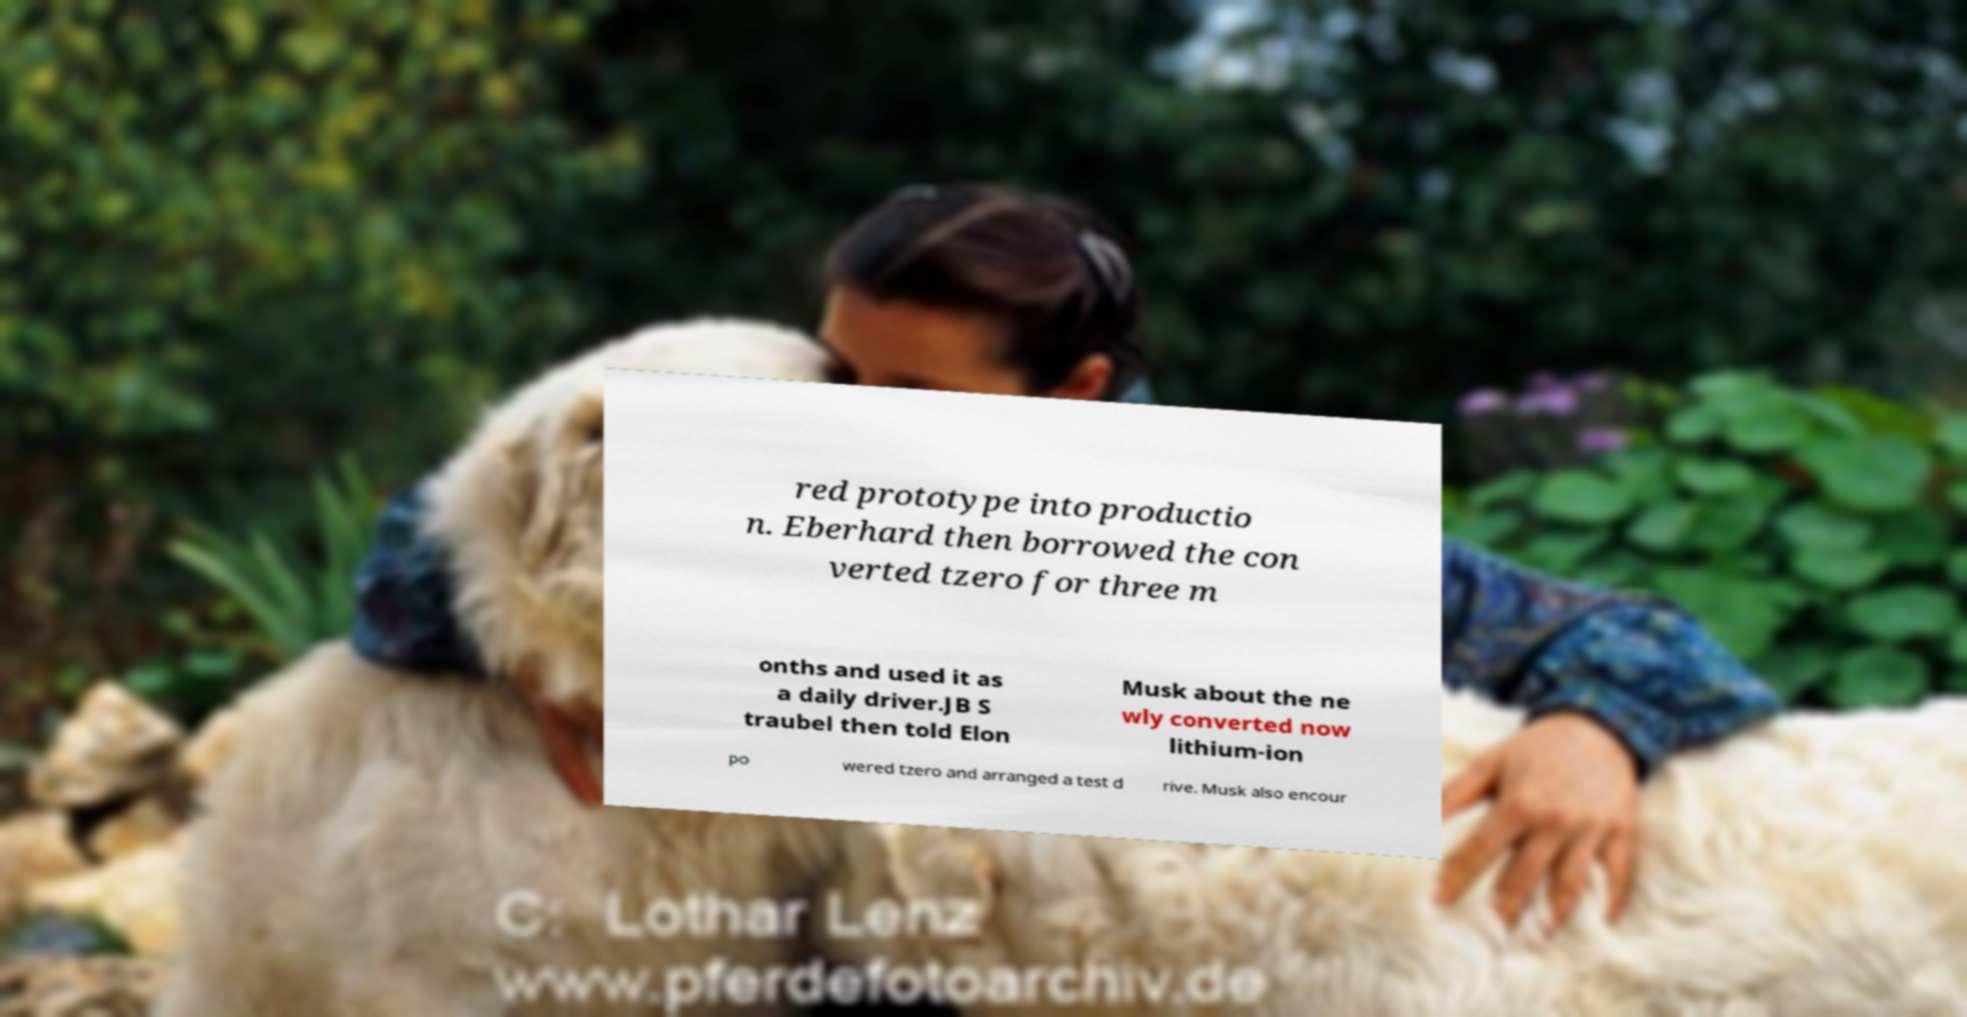Please read and relay the text visible in this image. What does it say? red prototype into productio n. Eberhard then borrowed the con verted tzero for three m onths and used it as a daily driver.JB S traubel then told Elon Musk about the ne wly converted now lithium-ion po wered tzero and arranged a test d rive. Musk also encour 